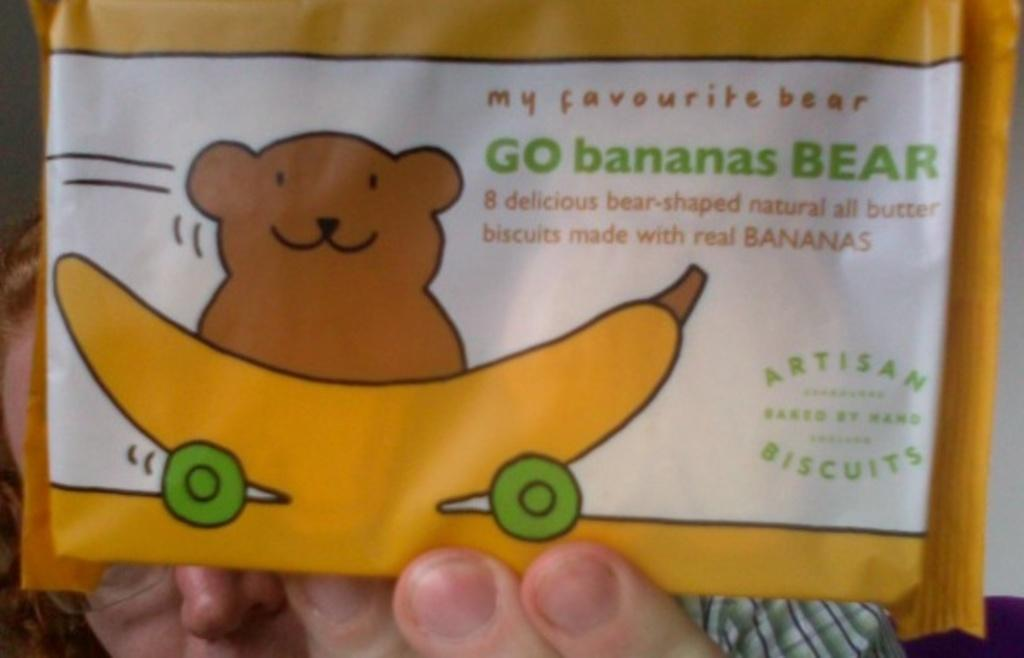Who is present in the image? There is a woman in the image. What is the woman holding? The woman is holding a packet. What can be seen on the packet? The packet has an image of a teddy bear and a banana. Is there any text on the packet? Yes, there is text on the packet. Can you see any hens in the image? There are no hens present in the image. What type of thrill can be experienced at the zoo depicted on the packet? There is no zoo depicted on the packet; it features an image of a teddy bear and a banana. 